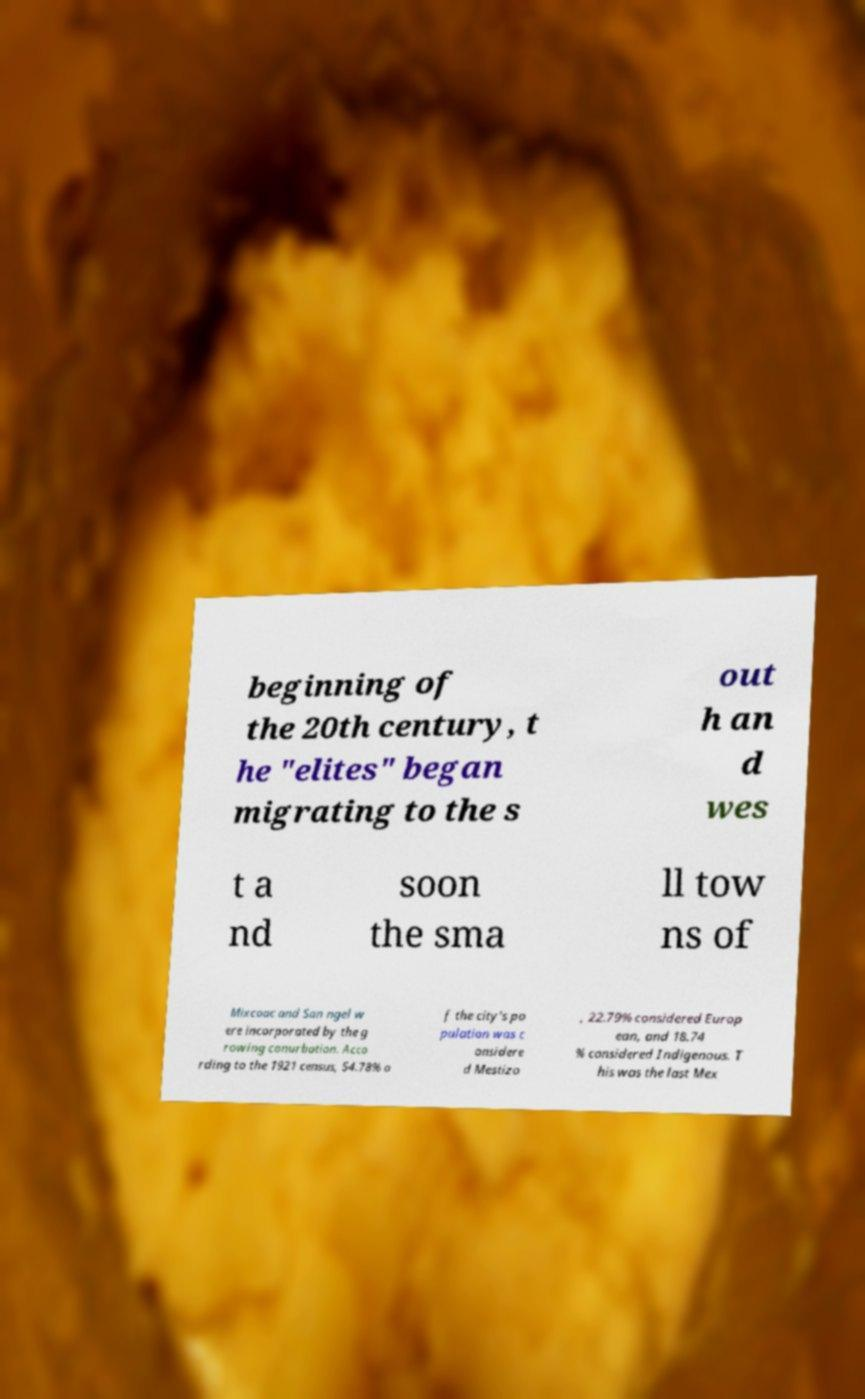What messages or text are displayed in this image? I need them in a readable, typed format. beginning of the 20th century, t he "elites" began migrating to the s out h an d wes t a nd soon the sma ll tow ns of Mixcoac and San ngel w ere incorporated by the g rowing conurbation. Acco rding to the 1921 census, 54.78% o f the city's po pulation was c onsidere d Mestizo , 22.79% considered Europ ean, and 18.74 % considered Indigenous. T his was the last Mex 